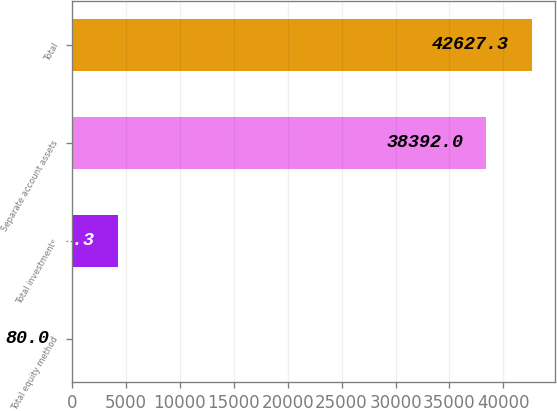Convert chart to OTSL. <chart><loc_0><loc_0><loc_500><loc_500><bar_chart><fcel>Total equity method<fcel>Total investments<fcel>Separate account assets<fcel>Total<nl><fcel>80<fcel>4315.3<fcel>38392<fcel>42627.3<nl></chart> 